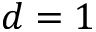<formula> <loc_0><loc_0><loc_500><loc_500>d = 1</formula> 